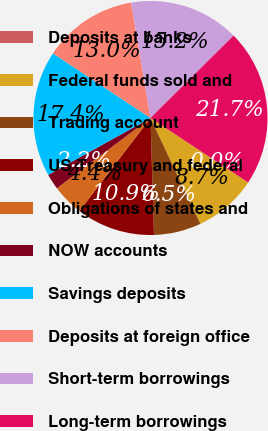<chart> <loc_0><loc_0><loc_500><loc_500><pie_chart><fcel>Deposits at banks<fcel>Federal funds sold and<fcel>Trading account<fcel>US Treasury and federal<fcel>Obligations of states and<fcel>NOW accounts<fcel>Savings deposits<fcel>Deposits at foreign office<fcel>Short-term borrowings<fcel>Long-term borrowings<nl><fcel>0.01%<fcel>8.7%<fcel>6.53%<fcel>10.87%<fcel>4.35%<fcel>2.18%<fcel>17.38%<fcel>13.04%<fcel>15.21%<fcel>21.72%<nl></chart> 